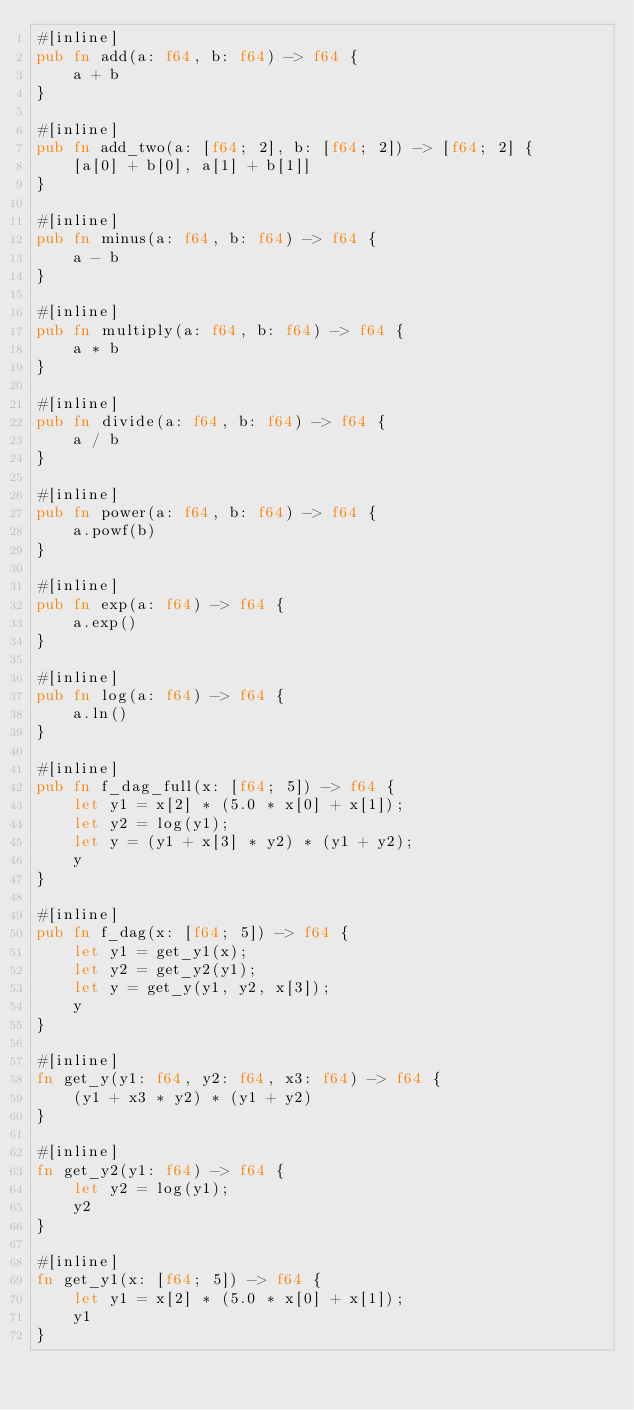Convert code to text. <code><loc_0><loc_0><loc_500><loc_500><_Rust_>#[inline]
pub fn add(a: f64, b: f64) -> f64 {
    a + b
}

#[inline]
pub fn add_two(a: [f64; 2], b: [f64; 2]) -> [f64; 2] {
    [a[0] + b[0], a[1] + b[1]]
}

#[inline]
pub fn minus(a: f64, b: f64) -> f64 {
    a - b
}

#[inline]
pub fn multiply(a: f64, b: f64) -> f64 {
    a * b
}

#[inline]
pub fn divide(a: f64, b: f64) -> f64 {
    a / b
}

#[inline]
pub fn power(a: f64, b: f64) -> f64 {
    a.powf(b)
}

#[inline]
pub fn exp(a: f64) -> f64 {
    a.exp()
}

#[inline]
pub fn log(a: f64) -> f64 {
    a.ln()
}

#[inline]
pub fn f_dag_full(x: [f64; 5]) -> f64 {
    let y1 = x[2] * (5.0 * x[0] + x[1]);
    let y2 = log(y1);
    let y = (y1 + x[3] * y2) * (y1 + y2);
    y
}

#[inline]
pub fn f_dag(x: [f64; 5]) -> f64 {
    let y1 = get_y1(x);
    let y2 = get_y2(y1);
    let y = get_y(y1, y2, x[3]);
    y
}

#[inline]
fn get_y(y1: f64, y2: f64, x3: f64) -> f64 {
    (y1 + x3 * y2) * (y1 + y2)
}

#[inline]
fn get_y2(y1: f64) -> f64 {
    let y2 = log(y1);
    y2
}

#[inline]
fn get_y1(x: [f64; 5]) -> f64 {
    let y1 = x[2] * (5.0 * x[0] + x[1]);
    y1
}
</code> 